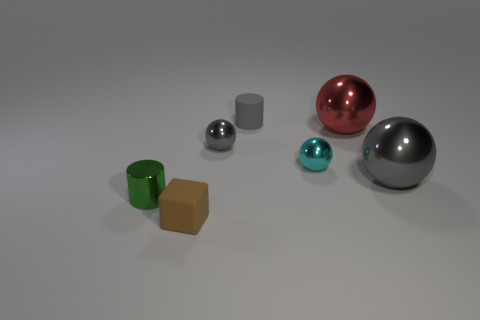What size is the ball on the left side of the small rubber object that is behind the green metallic thing?
Give a very brief answer. Small. Does the gray sphere that is right of the red metal sphere have the same size as the tiny matte cylinder?
Your response must be concise. No. Is the number of tiny metal things that are on the right side of the green metal cylinder greater than the number of brown rubber objects to the right of the cyan metal thing?
Offer a terse response. Yes. What shape is the small object that is in front of the small gray ball and behind the small green thing?
Your answer should be very brief. Sphere. There is a matte object in front of the small cyan metallic object; what is its shape?
Your response must be concise. Cube. There is a matte object behind the tiny metallic sphere that is left of the tiny rubber object that is behind the small green object; what is its size?
Offer a very short reply. Small. Does the red metal object have the same shape as the tiny cyan object?
Provide a short and direct response. Yes. There is a gray thing that is on the left side of the big red sphere and in front of the red metal object; how big is it?
Provide a succinct answer. Small. There is a big red thing that is the same shape as the cyan metallic object; what material is it?
Provide a succinct answer. Metal. The thing that is left of the small brown matte object that is in front of the small green cylinder is made of what material?
Offer a terse response. Metal. 